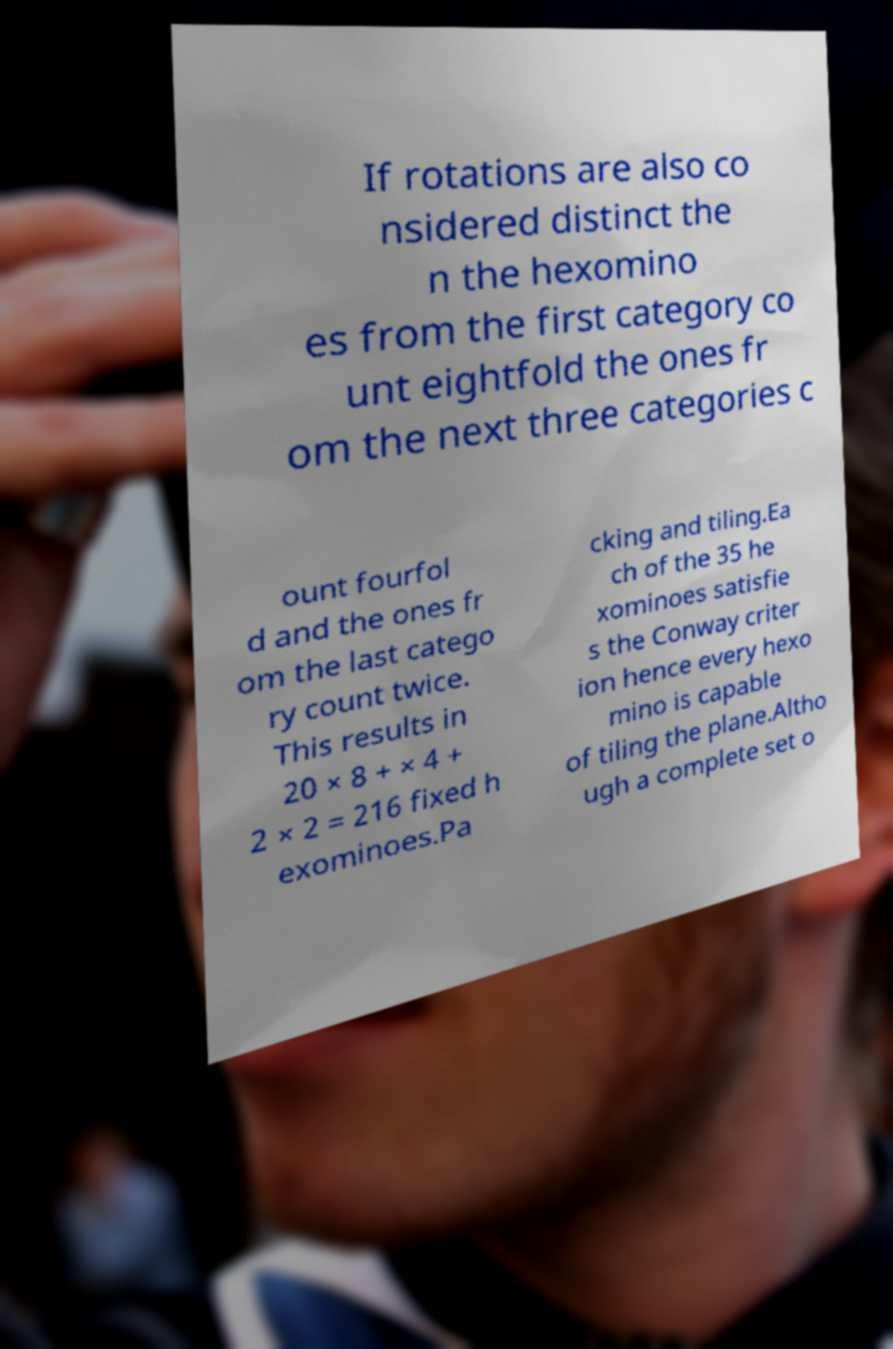Could you assist in decoding the text presented in this image and type it out clearly? If rotations are also co nsidered distinct the n the hexomino es from the first category co unt eightfold the ones fr om the next three categories c ount fourfol d and the ones fr om the last catego ry count twice. This results in 20 × 8 + × 4 + 2 × 2 = 216 fixed h exominoes.Pa cking and tiling.Ea ch of the 35 he xominoes satisfie s the Conway criter ion hence every hexo mino is capable of tiling the plane.Altho ugh a complete set o 